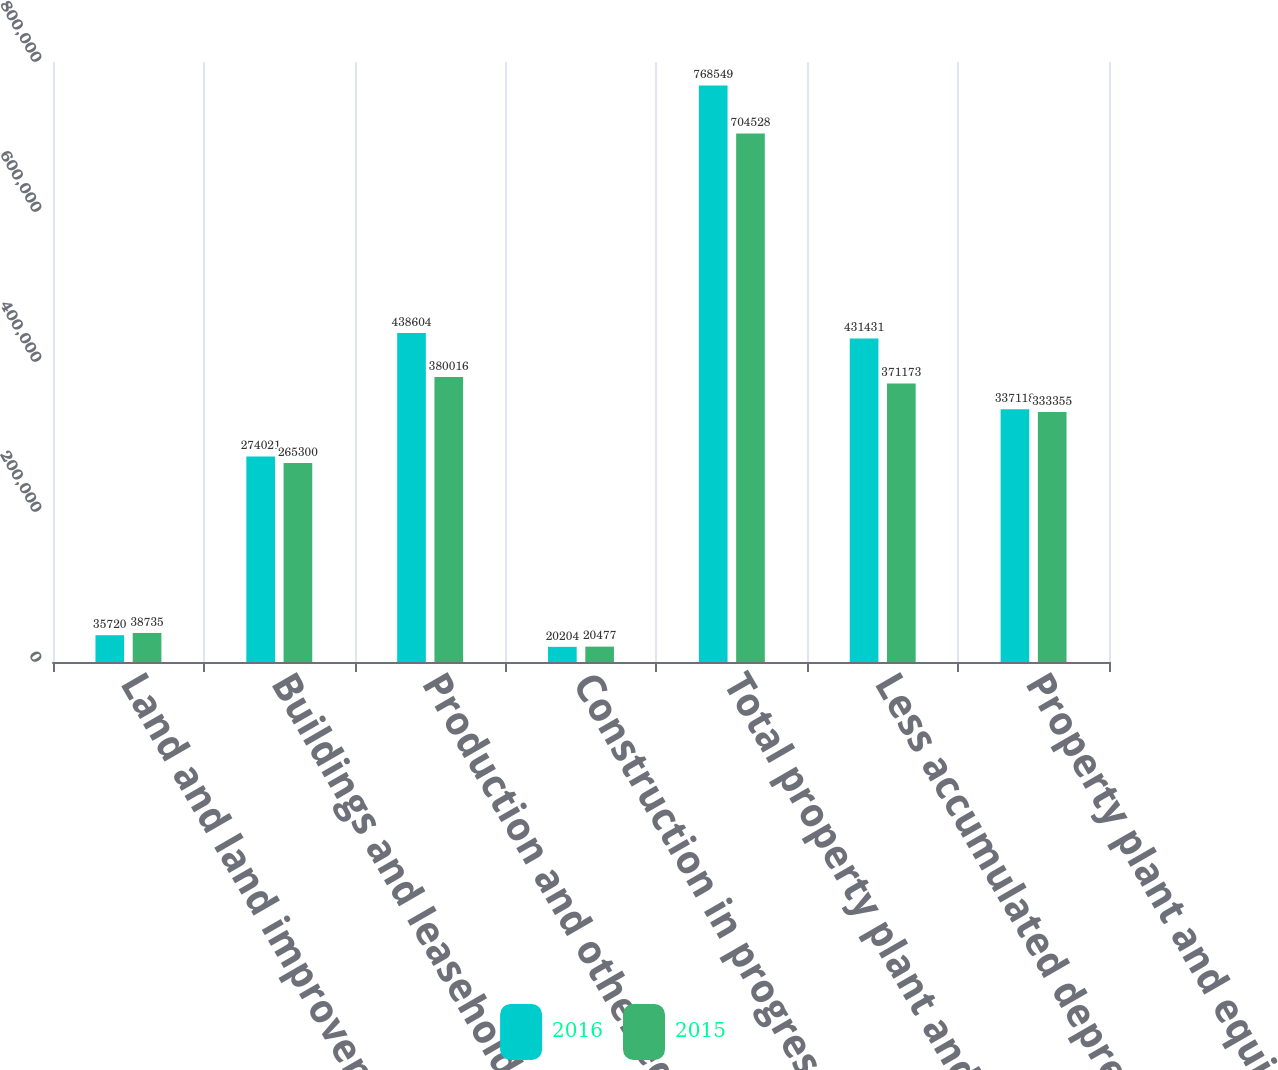Convert chart. <chart><loc_0><loc_0><loc_500><loc_500><stacked_bar_chart><ecel><fcel>Land and land improvements<fcel>Buildings and leasehold<fcel>Production and other equipment<fcel>Construction in progress<fcel>Total property plant and<fcel>Less accumulated depreciation<fcel>Property plant and equipment<nl><fcel>2016<fcel>35720<fcel>274021<fcel>438604<fcel>20204<fcel>768549<fcel>431431<fcel>337118<nl><fcel>2015<fcel>38735<fcel>265300<fcel>380016<fcel>20477<fcel>704528<fcel>371173<fcel>333355<nl></chart> 